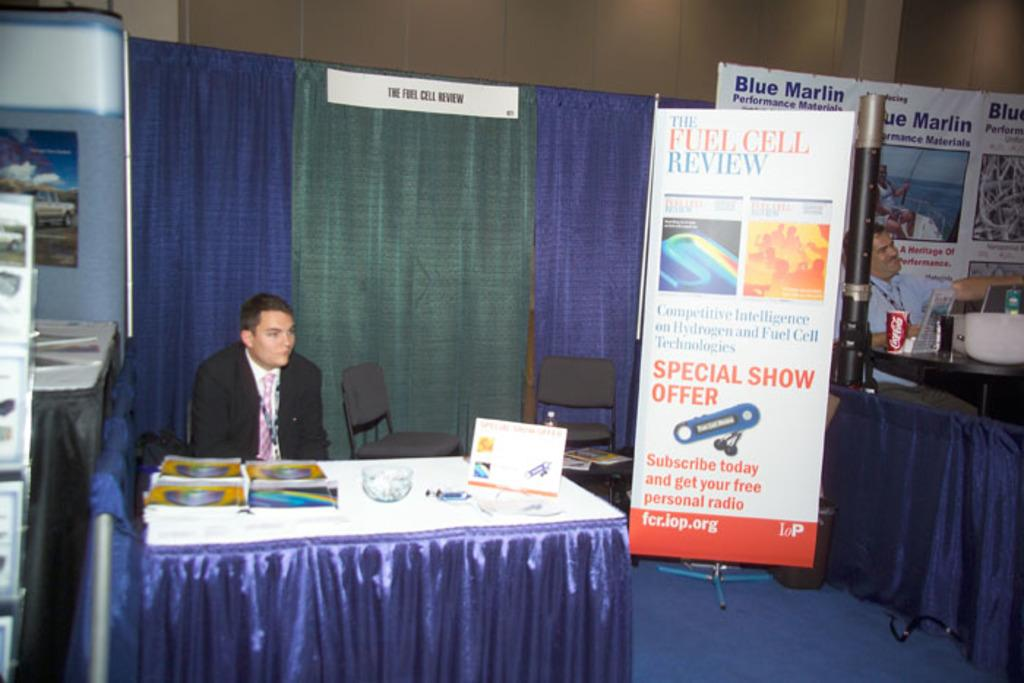<image>
Render a clear and concise summary of the photo. At an industry event, a man sits at a small table in the Fuel Cell Review booth. 